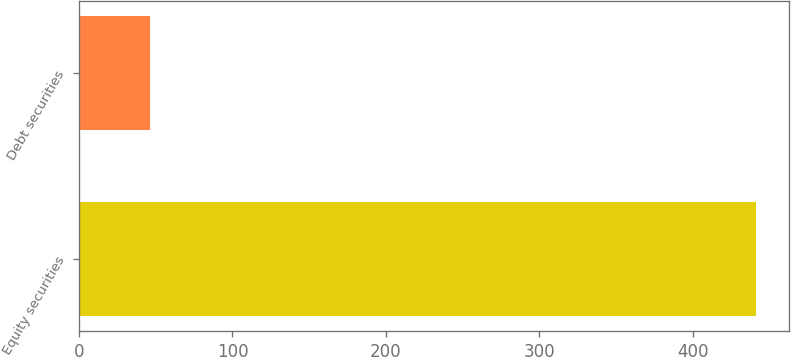Convert chart to OTSL. <chart><loc_0><loc_0><loc_500><loc_500><bar_chart><fcel>Equity securities<fcel>Debt securities<nl><fcel>441<fcel>46<nl></chart> 